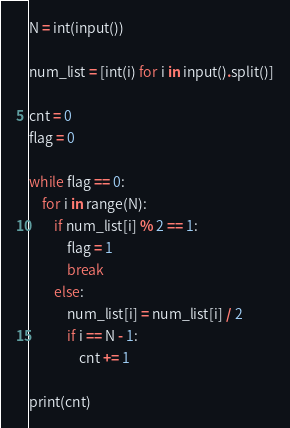Convert code to text. <code><loc_0><loc_0><loc_500><loc_500><_Python_>

N = int(input())

num_list = [int(i) for i in input().split()]

cnt = 0
flag = 0

while flag == 0:
    for i in range(N):
        if num_list[i] % 2 == 1:
            flag = 1
            break
        else:
            num_list[i] = num_list[i] / 2
            if i == N - 1:
                cnt += 1

print(cnt)
</code> 